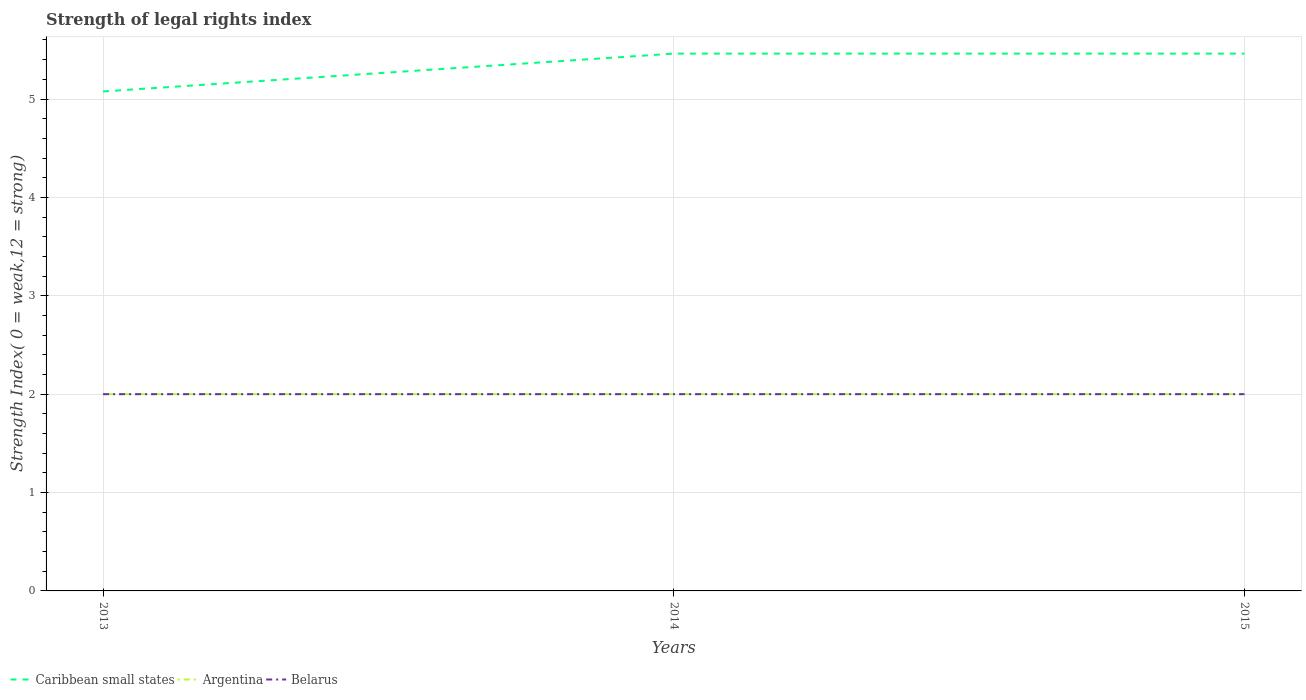How many different coloured lines are there?
Ensure brevity in your answer.  3. Does the line corresponding to Belarus intersect with the line corresponding to Argentina?
Offer a very short reply. Yes. Is the number of lines equal to the number of legend labels?
Offer a very short reply. Yes. Across all years, what is the maximum strength index in Caribbean small states?
Provide a short and direct response. 5.08. In which year was the strength index in Argentina maximum?
Keep it short and to the point. 2013. What is the difference between the highest and the second highest strength index in Argentina?
Keep it short and to the point. 0. How many years are there in the graph?
Provide a succinct answer. 3. Does the graph contain grids?
Ensure brevity in your answer.  Yes. Where does the legend appear in the graph?
Make the answer very short. Bottom left. How many legend labels are there?
Provide a short and direct response. 3. How are the legend labels stacked?
Provide a short and direct response. Horizontal. What is the title of the graph?
Your response must be concise. Strength of legal rights index. What is the label or title of the Y-axis?
Give a very brief answer. Strength Index( 0 = weak,12 = strong). What is the Strength Index( 0 = weak,12 = strong) of Caribbean small states in 2013?
Your answer should be compact. 5.08. What is the Strength Index( 0 = weak,12 = strong) of Argentina in 2013?
Offer a very short reply. 2. What is the Strength Index( 0 = weak,12 = strong) in Caribbean small states in 2014?
Provide a succinct answer. 5.46. What is the Strength Index( 0 = weak,12 = strong) of Argentina in 2014?
Offer a terse response. 2. What is the Strength Index( 0 = weak,12 = strong) in Caribbean small states in 2015?
Provide a short and direct response. 5.46. What is the Strength Index( 0 = weak,12 = strong) of Argentina in 2015?
Keep it short and to the point. 2. Across all years, what is the maximum Strength Index( 0 = weak,12 = strong) of Caribbean small states?
Make the answer very short. 5.46. Across all years, what is the minimum Strength Index( 0 = weak,12 = strong) of Caribbean small states?
Make the answer very short. 5.08. Across all years, what is the minimum Strength Index( 0 = weak,12 = strong) of Belarus?
Give a very brief answer. 2. What is the total Strength Index( 0 = weak,12 = strong) of Caribbean small states in the graph?
Ensure brevity in your answer.  16. What is the total Strength Index( 0 = weak,12 = strong) in Belarus in the graph?
Offer a terse response. 6. What is the difference between the Strength Index( 0 = weak,12 = strong) in Caribbean small states in 2013 and that in 2014?
Offer a very short reply. -0.38. What is the difference between the Strength Index( 0 = weak,12 = strong) of Caribbean small states in 2013 and that in 2015?
Ensure brevity in your answer.  -0.38. What is the difference between the Strength Index( 0 = weak,12 = strong) of Argentina in 2013 and that in 2015?
Give a very brief answer. 0. What is the difference between the Strength Index( 0 = weak,12 = strong) in Belarus in 2013 and that in 2015?
Provide a succinct answer. 0. What is the difference between the Strength Index( 0 = weak,12 = strong) in Caribbean small states in 2014 and that in 2015?
Offer a terse response. 0. What is the difference between the Strength Index( 0 = weak,12 = strong) in Belarus in 2014 and that in 2015?
Your answer should be very brief. 0. What is the difference between the Strength Index( 0 = weak,12 = strong) in Caribbean small states in 2013 and the Strength Index( 0 = weak,12 = strong) in Argentina in 2014?
Keep it short and to the point. 3.08. What is the difference between the Strength Index( 0 = weak,12 = strong) of Caribbean small states in 2013 and the Strength Index( 0 = weak,12 = strong) of Belarus in 2014?
Your answer should be very brief. 3.08. What is the difference between the Strength Index( 0 = weak,12 = strong) in Argentina in 2013 and the Strength Index( 0 = weak,12 = strong) in Belarus in 2014?
Give a very brief answer. 0. What is the difference between the Strength Index( 0 = weak,12 = strong) in Caribbean small states in 2013 and the Strength Index( 0 = weak,12 = strong) in Argentina in 2015?
Ensure brevity in your answer.  3.08. What is the difference between the Strength Index( 0 = weak,12 = strong) of Caribbean small states in 2013 and the Strength Index( 0 = weak,12 = strong) of Belarus in 2015?
Your answer should be compact. 3.08. What is the difference between the Strength Index( 0 = weak,12 = strong) of Argentina in 2013 and the Strength Index( 0 = weak,12 = strong) of Belarus in 2015?
Offer a very short reply. 0. What is the difference between the Strength Index( 0 = weak,12 = strong) of Caribbean small states in 2014 and the Strength Index( 0 = weak,12 = strong) of Argentina in 2015?
Your response must be concise. 3.46. What is the difference between the Strength Index( 0 = weak,12 = strong) in Caribbean small states in 2014 and the Strength Index( 0 = weak,12 = strong) in Belarus in 2015?
Offer a terse response. 3.46. What is the difference between the Strength Index( 0 = weak,12 = strong) of Argentina in 2014 and the Strength Index( 0 = weak,12 = strong) of Belarus in 2015?
Your answer should be very brief. 0. What is the average Strength Index( 0 = weak,12 = strong) of Caribbean small states per year?
Offer a very short reply. 5.33. What is the average Strength Index( 0 = weak,12 = strong) in Argentina per year?
Your response must be concise. 2. What is the average Strength Index( 0 = weak,12 = strong) in Belarus per year?
Ensure brevity in your answer.  2. In the year 2013, what is the difference between the Strength Index( 0 = weak,12 = strong) in Caribbean small states and Strength Index( 0 = weak,12 = strong) in Argentina?
Provide a succinct answer. 3.08. In the year 2013, what is the difference between the Strength Index( 0 = weak,12 = strong) of Caribbean small states and Strength Index( 0 = weak,12 = strong) of Belarus?
Make the answer very short. 3.08. In the year 2013, what is the difference between the Strength Index( 0 = weak,12 = strong) of Argentina and Strength Index( 0 = weak,12 = strong) of Belarus?
Ensure brevity in your answer.  0. In the year 2014, what is the difference between the Strength Index( 0 = weak,12 = strong) in Caribbean small states and Strength Index( 0 = weak,12 = strong) in Argentina?
Keep it short and to the point. 3.46. In the year 2014, what is the difference between the Strength Index( 0 = weak,12 = strong) of Caribbean small states and Strength Index( 0 = weak,12 = strong) of Belarus?
Your answer should be compact. 3.46. In the year 2014, what is the difference between the Strength Index( 0 = weak,12 = strong) in Argentina and Strength Index( 0 = weak,12 = strong) in Belarus?
Your answer should be compact. 0. In the year 2015, what is the difference between the Strength Index( 0 = weak,12 = strong) in Caribbean small states and Strength Index( 0 = weak,12 = strong) in Argentina?
Provide a short and direct response. 3.46. In the year 2015, what is the difference between the Strength Index( 0 = weak,12 = strong) in Caribbean small states and Strength Index( 0 = weak,12 = strong) in Belarus?
Provide a succinct answer. 3.46. What is the ratio of the Strength Index( 0 = weak,12 = strong) of Caribbean small states in 2013 to that in 2014?
Offer a very short reply. 0.93. What is the ratio of the Strength Index( 0 = weak,12 = strong) in Argentina in 2013 to that in 2014?
Make the answer very short. 1. What is the ratio of the Strength Index( 0 = weak,12 = strong) of Caribbean small states in 2013 to that in 2015?
Your response must be concise. 0.93. What is the ratio of the Strength Index( 0 = weak,12 = strong) of Argentina in 2013 to that in 2015?
Provide a succinct answer. 1. What is the ratio of the Strength Index( 0 = weak,12 = strong) of Caribbean small states in 2014 to that in 2015?
Your answer should be compact. 1. What is the ratio of the Strength Index( 0 = weak,12 = strong) of Argentina in 2014 to that in 2015?
Provide a succinct answer. 1. What is the ratio of the Strength Index( 0 = weak,12 = strong) of Belarus in 2014 to that in 2015?
Your answer should be very brief. 1. What is the difference between the highest and the lowest Strength Index( 0 = weak,12 = strong) in Caribbean small states?
Provide a short and direct response. 0.38. What is the difference between the highest and the lowest Strength Index( 0 = weak,12 = strong) in Argentina?
Offer a terse response. 0. What is the difference between the highest and the lowest Strength Index( 0 = weak,12 = strong) of Belarus?
Provide a short and direct response. 0. 